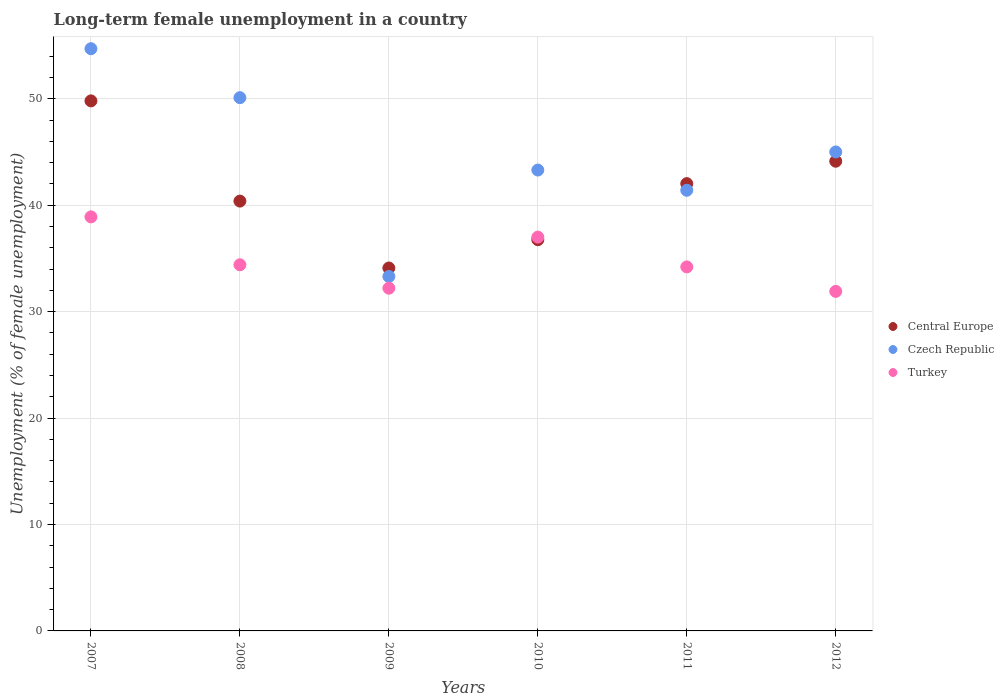How many different coloured dotlines are there?
Your answer should be very brief. 3. Is the number of dotlines equal to the number of legend labels?
Ensure brevity in your answer.  Yes. What is the percentage of long-term unemployed female population in Czech Republic in 2009?
Provide a succinct answer. 33.3. Across all years, what is the maximum percentage of long-term unemployed female population in Central Europe?
Your answer should be compact. 49.8. Across all years, what is the minimum percentage of long-term unemployed female population in Czech Republic?
Your answer should be compact. 33.3. In which year was the percentage of long-term unemployed female population in Central Europe minimum?
Offer a very short reply. 2009. What is the total percentage of long-term unemployed female population in Turkey in the graph?
Provide a short and direct response. 208.6. What is the difference between the percentage of long-term unemployed female population in Central Europe in 2008 and that in 2012?
Your response must be concise. -3.75. What is the difference between the percentage of long-term unemployed female population in Turkey in 2008 and the percentage of long-term unemployed female population in Central Europe in 2007?
Keep it short and to the point. -15.4. What is the average percentage of long-term unemployed female population in Czech Republic per year?
Provide a succinct answer. 44.63. In the year 2012, what is the difference between the percentage of long-term unemployed female population in Czech Republic and percentage of long-term unemployed female population in Turkey?
Give a very brief answer. 13.1. What is the ratio of the percentage of long-term unemployed female population in Central Europe in 2008 to that in 2009?
Offer a very short reply. 1.18. Is the difference between the percentage of long-term unemployed female population in Czech Republic in 2007 and 2008 greater than the difference between the percentage of long-term unemployed female population in Turkey in 2007 and 2008?
Your answer should be very brief. Yes. What is the difference between the highest and the second highest percentage of long-term unemployed female population in Turkey?
Offer a very short reply. 1.9. What is the difference between the highest and the lowest percentage of long-term unemployed female population in Turkey?
Provide a succinct answer. 7. Is the sum of the percentage of long-term unemployed female population in Czech Republic in 2009 and 2010 greater than the maximum percentage of long-term unemployed female population in Turkey across all years?
Offer a terse response. Yes. How many dotlines are there?
Your answer should be very brief. 3. How many years are there in the graph?
Give a very brief answer. 6. What is the difference between two consecutive major ticks on the Y-axis?
Keep it short and to the point. 10. Does the graph contain any zero values?
Keep it short and to the point. No. What is the title of the graph?
Your answer should be very brief. Long-term female unemployment in a country. What is the label or title of the X-axis?
Give a very brief answer. Years. What is the label or title of the Y-axis?
Keep it short and to the point. Unemployment (% of female unemployment). What is the Unemployment (% of female unemployment) of Central Europe in 2007?
Your answer should be very brief. 49.8. What is the Unemployment (% of female unemployment) of Czech Republic in 2007?
Ensure brevity in your answer.  54.7. What is the Unemployment (% of female unemployment) of Turkey in 2007?
Your answer should be very brief. 38.9. What is the Unemployment (% of female unemployment) of Central Europe in 2008?
Provide a short and direct response. 40.38. What is the Unemployment (% of female unemployment) in Czech Republic in 2008?
Offer a terse response. 50.1. What is the Unemployment (% of female unemployment) of Turkey in 2008?
Provide a short and direct response. 34.4. What is the Unemployment (% of female unemployment) of Central Europe in 2009?
Ensure brevity in your answer.  34.1. What is the Unemployment (% of female unemployment) of Czech Republic in 2009?
Provide a short and direct response. 33.3. What is the Unemployment (% of female unemployment) of Turkey in 2009?
Make the answer very short. 32.2. What is the Unemployment (% of female unemployment) in Central Europe in 2010?
Give a very brief answer. 36.75. What is the Unemployment (% of female unemployment) of Czech Republic in 2010?
Your answer should be compact. 43.3. What is the Unemployment (% of female unemployment) of Turkey in 2010?
Offer a very short reply. 37. What is the Unemployment (% of female unemployment) in Central Europe in 2011?
Offer a terse response. 42.02. What is the Unemployment (% of female unemployment) of Czech Republic in 2011?
Provide a short and direct response. 41.4. What is the Unemployment (% of female unemployment) of Turkey in 2011?
Your answer should be very brief. 34.2. What is the Unemployment (% of female unemployment) of Central Europe in 2012?
Give a very brief answer. 44.13. What is the Unemployment (% of female unemployment) of Turkey in 2012?
Offer a very short reply. 31.9. Across all years, what is the maximum Unemployment (% of female unemployment) of Central Europe?
Keep it short and to the point. 49.8. Across all years, what is the maximum Unemployment (% of female unemployment) of Czech Republic?
Your answer should be compact. 54.7. Across all years, what is the maximum Unemployment (% of female unemployment) in Turkey?
Make the answer very short. 38.9. Across all years, what is the minimum Unemployment (% of female unemployment) in Central Europe?
Ensure brevity in your answer.  34.1. Across all years, what is the minimum Unemployment (% of female unemployment) of Czech Republic?
Your answer should be very brief. 33.3. Across all years, what is the minimum Unemployment (% of female unemployment) of Turkey?
Your answer should be very brief. 31.9. What is the total Unemployment (% of female unemployment) in Central Europe in the graph?
Provide a short and direct response. 247.19. What is the total Unemployment (% of female unemployment) of Czech Republic in the graph?
Your response must be concise. 267.8. What is the total Unemployment (% of female unemployment) in Turkey in the graph?
Keep it short and to the point. 208.6. What is the difference between the Unemployment (% of female unemployment) in Central Europe in 2007 and that in 2008?
Your answer should be compact. 9.42. What is the difference between the Unemployment (% of female unemployment) of Turkey in 2007 and that in 2008?
Make the answer very short. 4.5. What is the difference between the Unemployment (% of female unemployment) in Central Europe in 2007 and that in 2009?
Make the answer very short. 15.7. What is the difference between the Unemployment (% of female unemployment) of Czech Republic in 2007 and that in 2009?
Your answer should be compact. 21.4. What is the difference between the Unemployment (% of female unemployment) of Turkey in 2007 and that in 2009?
Keep it short and to the point. 6.7. What is the difference between the Unemployment (% of female unemployment) in Central Europe in 2007 and that in 2010?
Keep it short and to the point. 13.04. What is the difference between the Unemployment (% of female unemployment) of Turkey in 2007 and that in 2010?
Provide a short and direct response. 1.9. What is the difference between the Unemployment (% of female unemployment) in Central Europe in 2007 and that in 2011?
Ensure brevity in your answer.  7.77. What is the difference between the Unemployment (% of female unemployment) of Central Europe in 2007 and that in 2012?
Provide a short and direct response. 5.67. What is the difference between the Unemployment (% of female unemployment) in Czech Republic in 2007 and that in 2012?
Offer a terse response. 9.7. What is the difference between the Unemployment (% of female unemployment) in Central Europe in 2008 and that in 2009?
Give a very brief answer. 6.29. What is the difference between the Unemployment (% of female unemployment) of Czech Republic in 2008 and that in 2009?
Offer a terse response. 16.8. What is the difference between the Unemployment (% of female unemployment) in Turkey in 2008 and that in 2009?
Offer a terse response. 2.2. What is the difference between the Unemployment (% of female unemployment) of Central Europe in 2008 and that in 2010?
Ensure brevity in your answer.  3.63. What is the difference between the Unemployment (% of female unemployment) in Turkey in 2008 and that in 2010?
Ensure brevity in your answer.  -2.6. What is the difference between the Unemployment (% of female unemployment) in Central Europe in 2008 and that in 2011?
Your answer should be compact. -1.64. What is the difference between the Unemployment (% of female unemployment) in Czech Republic in 2008 and that in 2011?
Offer a terse response. 8.7. What is the difference between the Unemployment (% of female unemployment) of Central Europe in 2008 and that in 2012?
Offer a very short reply. -3.75. What is the difference between the Unemployment (% of female unemployment) of Central Europe in 2009 and that in 2010?
Your answer should be compact. -2.66. What is the difference between the Unemployment (% of female unemployment) in Central Europe in 2009 and that in 2011?
Your answer should be compact. -7.93. What is the difference between the Unemployment (% of female unemployment) of Turkey in 2009 and that in 2011?
Keep it short and to the point. -2. What is the difference between the Unemployment (% of female unemployment) in Central Europe in 2009 and that in 2012?
Keep it short and to the point. -10.03. What is the difference between the Unemployment (% of female unemployment) in Czech Republic in 2009 and that in 2012?
Your answer should be compact. -11.7. What is the difference between the Unemployment (% of female unemployment) in Turkey in 2009 and that in 2012?
Provide a succinct answer. 0.3. What is the difference between the Unemployment (% of female unemployment) in Central Europe in 2010 and that in 2011?
Offer a very short reply. -5.27. What is the difference between the Unemployment (% of female unemployment) of Czech Republic in 2010 and that in 2011?
Your answer should be compact. 1.9. What is the difference between the Unemployment (% of female unemployment) in Central Europe in 2010 and that in 2012?
Your answer should be compact. -7.37. What is the difference between the Unemployment (% of female unemployment) of Turkey in 2010 and that in 2012?
Ensure brevity in your answer.  5.1. What is the difference between the Unemployment (% of female unemployment) in Central Europe in 2011 and that in 2012?
Provide a succinct answer. -2.1. What is the difference between the Unemployment (% of female unemployment) of Central Europe in 2007 and the Unemployment (% of female unemployment) of Czech Republic in 2008?
Give a very brief answer. -0.3. What is the difference between the Unemployment (% of female unemployment) in Central Europe in 2007 and the Unemployment (% of female unemployment) in Turkey in 2008?
Make the answer very short. 15.4. What is the difference between the Unemployment (% of female unemployment) of Czech Republic in 2007 and the Unemployment (% of female unemployment) of Turkey in 2008?
Provide a short and direct response. 20.3. What is the difference between the Unemployment (% of female unemployment) of Central Europe in 2007 and the Unemployment (% of female unemployment) of Czech Republic in 2009?
Offer a very short reply. 16.5. What is the difference between the Unemployment (% of female unemployment) in Central Europe in 2007 and the Unemployment (% of female unemployment) in Turkey in 2009?
Your answer should be very brief. 17.6. What is the difference between the Unemployment (% of female unemployment) in Central Europe in 2007 and the Unemployment (% of female unemployment) in Czech Republic in 2010?
Your response must be concise. 6.5. What is the difference between the Unemployment (% of female unemployment) in Central Europe in 2007 and the Unemployment (% of female unemployment) in Turkey in 2010?
Your answer should be compact. 12.8. What is the difference between the Unemployment (% of female unemployment) of Czech Republic in 2007 and the Unemployment (% of female unemployment) of Turkey in 2010?
Keep it short and to the point. 17.7. What is the difference between the Unemployment (% of female unemployment) of Central Europe in 2007 and the Unemployment (% of female unemployment) of Czech Republic in 2011?
Make the answer very short. 8.4. What is the difference between the Unemployment (% of female unemployment) of Central Europe in 2007 and the Unemployment (% of female unemployment) of Turkey in 2011?
Your answer should be very brief. 15.6. What is the difference between the Unemployment (% of female unemployment) of Czech Republic in 2007 and the Unemployment (% of female unemployment) of Turkey in 2011?
Give a very brief answer. 20.5. What is the difference between the Unemployment (% of female unemployment) of Central Europe in 2007 and the Unemployment (% of female unemployment) of Czech Republic in 2012?
Your answer should be compact. 4.8. What is the difference between the Unemployment (% of female unemployment) in Central Europe in 2007 and the Unemployment (% of female unemployment) in Turkey in 2012?
Give a very brief answer. 17.9. What is the difference between the Unemployment (% of female unemployment) in Czech Republic in 2007 and the Unemployment (% of female unemployment) in Turkey in 2012?
Make the answer very short. 22.8. What is the difference between the Unemployment (% of female unemployment) in Central Europe in 2008 and the Unemployment (% of female unemployment) in Czech Republic in 2009?
Provide a short and direct response. 7.08. What is the difference between the Unemployment (% of female unemployment) of Central Europe in 2008 and the Unemployment (% of female unemployment) of Turkey in 2009?
Give a very brief answer. 8.18. What is the difference between the Unemployment (% of female unemployment) in Central Europe in 2008 and the Unemployment (% of female unemployment) in Czech Republic in 2010?
Give a very brief answer. -2.92. What is the difference between the Unemployment (% of female unemployment) of Central Europe in 2008 and the Unemployment (% of female unemployment) of Turkey in 2010?
Offer a terse response. 3.38. What is the difference between the Unemployment (% of female unemployment) of Czech Republic in 2008 and the Unemployment (% of female unemployment) of Turkey in 2010?
Ensure brevity in your answer.  13.1. What is the difference between the Unemployment (% of female unemployment) of Central Europe in 2008 and the Unemployment (% of female unemployment) of Czech Republic in 2011?
Your response must be concise. -1.02. What is the difference between the Unemployment (% of female unemployment) in Central Europe in 2008 and the Unemployment (% of female unemployment) in Turkey in 2011?
Make the answer very short. 6.18. What is the difference between the Unemployment (% of female unemployment) of Czech Republic in 2008 and the Unemployment (% of female unemployment) of Turkey in 2011?
Offer a terse response. 15.9. What is the difference between the Unemployment (% of female unemployment) in Central Europe in 2008 and the Unemployment (% of female unemployment) in Czech Republic in 2012?
Make the answer very short. -4.62. What is the difference between the Unemployment (% of female unemployment) of Central Europe in 2008 and the Unemployment (% of female unemployment) of Turkey in 2012?
Make the answer very short. 8.48. What is the difference between the Unemployment (% of female unemployment) in Central Europe in 2009 and the Unemployment (% of female unemployment) in Czech Republic in 2010?
Make the answer very short. -9.2. What is the difference between the Unemployment (% of female unemployment) of Central Europe in 2009 and the Unemployment (% of female unemployment) of Turkey in 2010?
Your response must be concise. -2.9. What is the difference between the Unemployment (% of female unemployment) in Central Europe in 2009 and the Unemployment (% of female unemployment) in Czech Republic in 2011?
Offer a terse response. -7.3. What is the difference between the Unemployment (% of female unemployment) in Central Europe in 2009 and the Unemployment (% of female unemployment) in Turkey in 2011?
Provide a succinct answer. -0.1. What is the difference between the Unemployment (% of female unemployment) of Czech Republic in 2009 and the Unemployment (% of female unemployment) of Turkey in 2011?
Make the answer very short. -0.9. What is the difference between the Unemployment (% of female unemployment) in Central Europe in 2009 and the Unemployment (% of female unemployment) in Czech Republic in 2012?
Your response must be concise. -10.9. What is the difference between the Unemployment (% of female unemployment) of Central Europe in 2009 and the Unemployment (% of female unemployment) of Turkey in 2012?
Make the answer very short. 2.2. What is the difference between the Unemployment (% of female unemployment) of Central Europe in 2010 and the Unemployment (% of female unemployment) of Czech Republic in 2011?
Give a very brief answer. -4.65. What is the difference between the Unemployment (% of female unemployment) of Central Europe in 2010 and the Unemployment (% of female unemployment) of Turkey in 2011?
Your response must be concise. 2.55. What is the difference between the Unemployment (% of female unemployment) of Czech Republic in 2010 and the Unemployment (% of female unemployment) of Turkey in 2011?
Ensure brevity in your answer.  9.1. What is the difference between the Unemployment (% of female unemployment) in Central Europe in 2010 and the Unemployment (% of female unemployment) in Czech Republic in 2012?
Offer a terse response. -8.25. What is the difference between the Unemployment (% of female unemployment) of Central Europe in 2010 and the Unemployment (% of female unemployment) of Turkey in 2012?
Keep it short and to the point. 4.85. What is the difference between the Unemployment (% of female unemployment) in Czech Republic in 2010 and the Unemployment (% of female unemployment) in Turkey in 2012?
Your answer should be very brief. 11.4. What is the difference between the Unemployment (% of female unemployment) in Central Europe in 2011 and the Unemployment (% of female unemployment) in Czech Republic in 2012?
Your answer should be very brief. -2.98. What is the difference between the Unemployment (% of female unemployment) in Central Europe in 2011 and the Unemployment (% of female unemployment) in Turkey in 2012?
Ensure brevity in your answer.  10.12. What is the average Unemployment (% of female unemployment) in Central Europe per year?
Your answer should be very brief. 41.2. What is the average Unemployment (% of female unemployment) in Czech Republic per year?
Make the answer very short. 44.63. What is the average Unemployment (% of female unemployment) of Turkey per year?
Make the answer very short. 34.77. In the year 2007, what is the difference between the Unemployment (% of female unemployment) in Central Europe and Unemployment (% of female unemployment) in Czech Republic?
Your answer should be very brief. -4.9. In the year 2007, what is the difference between the Unemployment (% of female unemployment) of Central Europe and Unemployment (% of female unemployment) of Turkey?
Your answer should be very brief. 10.9. In the year 2008, what is the difference between the Unemployment (% of female unemployment) of Central Europe and Unemployment (% of female unemployment) of Czech Republic?
Offer a terse response. -9.72. In the year 2008, what is the difference between the Unemployment (% of female unemployment) of Central Europe and Unemployment (% of female unemployment) of Turkey?
Your answer should be very brief. 5.98. In the year 2009, what is the difference between the Unemployment (% of female unemployment) in Central Europe and Unemployment (% of female unemployment) in Czech Republic?
Keep it short and to the point. 0.8. In the year 2009, what is the difference between the Unemployment (% of female unemployment) in Central Europe and Unemployment (% of female unemployment) in Turkey?
Give a very brief answer. 1.9. In the year 2009, what is the difference between the Unemployment (% of female unemployment) of Czech Republic and Unemployment (% of female unemployment) of Turkey?
Your answer should be compact. 1.1. In the year 2010, what is the difference between the Unemployment (% of female unemployment) of Central Europe and Unemployment (% of female unemployment) of Czech Republic?
Your answer should be compact. -6.55. In the year 2010, what is the difference between the Unemployment (% of female unemployment) in Central Europe and Unemployment (% of female unemployment) in Turkey?
Give a very brief answer. -0.25. In the year 2010, what is the difference between the Unemployment (% of female unemployment) in Czech Republic and Unemployment (% of female unemployment) in Turkey?
Keep it short and to the point. 6.3. In the year 2011, what is the difference between the Unemployment (% of female unemployment) of Central Europe and Unemployment (% of female unemployment) of Czech Republic?
Make the answer very short. 0.62. In the year 2011, what is the difference between the Unemployment (% of female unemployment) in Central Europe and Unemployment (% of female unemployment) in Turkey?
Give a very brief answer. 7.82. In the year 2011, what is the difference between the Unemployment (% of female unemployment) of Czech Republic and Unemployment (% of female unemployment) of Turkey?
Your response must be concise. 7.2. In the year 2012, what is the difference between the Unemployment (% of female unemployment) of Central Europe and Unemployment (% of female unemployment) of Czech Republic?
Your answer should be very brief. -0.87. In the year 2012, what is the difference between the Unemployment (% of female unemployment) of Central Europe and Unemployment (% of female unemployment) of Turkey?
Your answer should be compact. 12.23. In the year 2012, what is the difference between the Unemployment (% of female unemployment) in Czech Republic and Unemployment (% of female unemployment) in Turkey?
Your response must be concise. 13.1. What is the ratio of the Unemployment (% of female unemployment) of Central Europe in 2007 to that in 2008?
Offer a very short reply. 1.23. What is the ratio of the Unemployment (% of female unemployment) of Czech Republic in 2007 to that in 2008?
Provide a succinct answer. 1.09. What is the ratio of the Unemployment (% of female unemployment) of Turkey in 2007 to that in 2008?
Your answer should be compact. 1.13. What is the ratio of the Unemployment (% of female unemployment) of Central Europe in 2007 to that in 2009?
Offer a very short reply. 1.46. What is the ratio of the Unemployment (% of female unemployment) in Czech Republic in 2007 to that in 2009?
Your answer should be compact. 1.64. What is the ratio of the Unemployment (% of female unemployment) in Turkey in 2007 to that in 2009?
Your response must be concise. 1.21. What is the ratio of the Unemployment (% of female unemployment) in Central Europe in 2007 to that in 2010?
Provide a short and direct response. 1.35. What is the ratio of the Unemployment (% of female unemployment) of Czech Republic in 2007 to that in 2010?
Provide a short and direct response. 1.26. What is the ratio of the Unemployment (% of female unemployment) in Turkey in 2007 to that in 2010?
Your response must be concise. 1.05. What is the ratio of the Unemployment (% of female unemployment) in Central Europe in 2007 to that in 2011?
Your answer should be very brief. 1.19. What is the ratio of the Unemployment (% of female unemployment) in Czech Republic in 2007 to that in 2011?
Offer a very short reply. 1.32. What is the ratio of the Unemployment (% of female unemployment) of Turkey in 2007 to that in 2011?
Your answer should be very brief. 1.14. What is the ratio of the Unemployment (% of female unemployment) in Central Europe in 2007 to that in 2012?
Ensure brevity in your answer.  1.13. What is the ratio of the Unemployment (% of female unemployment) of Czech Republic in 2007 to that in 2012?
Your answer should be compact. 1.22. What is the ratio of the Unemployment (% of female unemployment) of Turkey in 2007 to that in 2012?
Provide a short and direct response. 1.22. What is the ratio of the Unemployment (% of female unemployment) in Central Europe in 2008 to that in 2009?
Give a very brief answer. 1.18. What is the ratio of the Unemployment (% of female unemployment) of Czech Republic in 2008 to that in 2009?
Offer a very short reply. 1.5. What is the ratio of the Unemployment (% of female unemployment) in Turkey in 2008 to that in 2009?
Provide a succinct answer. 1.07. What is the ratio of the Unemployment (% of female unemployment) of Central Europe in 2008 to that in 2010?
Ensure brevity in your answer.  1.1. What is the ratio of the Unemployment (% of female unemployment) in Czech Republic in 2008 to that in 2010?
Offer a terse response. 1.16. What is the ratio of the Unemployment (% of female unemployment) in Turkey in 2008 to that in 2010?
Offer a terse response. 0.93. What is the ratio of the Unemployment (% of female unemployment) of Czech Republic in 2008 to that in 2011?
Your answer should be very brief. 1.21. What is the ratio of the Unemployment (% of female unemployment) of Turkey in 2008 to that in 2011?
Offer a terse response. 1.01. What is the ratio of the Unemployment (% of female unemployment) of Central Europe in 2008 to that in 2012?
Make the answer very short. 0.92. What is the ratio of the Unemployment (% of female unemployment) of Czech Republic in 2008 to that in 2012?
Offer a terse response. 1.11. What is the ratio of the Unemployment (% of female unemployment) of Turkey in 2008 to that in 2012?
Offer a very short reply. 1.08. What is the ratio of the Unemployment (% of female unemployment) of Central Europe in 2009 to that in 2010?
Provide a succinct answer. 0.93. What is the ratio of the Unemployment (% of female unemployment) in Czech Republic in 2009 to that in 2010?
Give a very brief answer. 0.77. What is the ratio of the Unemployment (% of female unemployment) in Turkey in 2009 to that in 2010?
Provide a succinct answer. 0.87. What is the ratio of the Unemployment (% of female unemployment) of Central Europe in 2009 to that in 2011?
Your response must be concise. 0.81. What is the ratio of the Unemployment (% of female unemployment) in Czech Republic in 2009 to that in 2011?
Your answer should be very brief. 0.8. What is the ratio of the Unemployment (% of female unemployment) in Turkey in 2009 to that in 2011?
Give a very brief answer. 0.94. What is the ratio of the Unemployment (% of female unemployment) of Central Europe in 2009 to that in 2012?
Keep it short and to the point. 0.77. What is the ratio of the Unemployment (% of female unemployment) in Czech Republic in 2009 to that in 2012?
Keep it short and to the point. 0.74. What is the ratio of the Unemployment (% of female unemployment) in Turkey in 2009 to that in 2012?
Give a very brief answer. 1.01. What is the ratio of the Unemployment (% of female unemployment) in Central Europe in 2010 to that in 2011?
Ensure brevity in your answer.  0.87. What is the ratio of the Unemployment (% of female unemployment) of Czech Republic in 2010 to that in 2011?
Offer a very short reply. 1.05. What is the ratio of the Unemployment (% of female unemployment) in Turkey in 2010 to that in 2011?
Your answer should be compact. 1.08. What is the ratio of the Unemployment (% of female unemployment) in Central Europe in 2010 to that in 2012?
Provide a short and direct response. 0.83. What is the ratio of the Unemployment (% of female unemployment) in Czech Republic in 2010 to that in 2012?
Ensure brevity in your answer.  0.96. What is the ratio of the Unemployment (% of female unemployment) of Turkey in 2010 to that in 2012?
Ensure brevity in your answer.  1.16. What is the ratio of the Unemployment (% of female unemployment) of Central Europe in 2011 to that in 2012?
Give a very brief answer. 0.95. What is the ratio of the Unemployment (% of female unemployment) in Czech Republic in 2011 to that in 2012?
Offer a terse response. 0.92. What is the ratio of the Unemployment (% of female unemployment) in Turkey in 2011 to that in 2012?
Offer a very short reply. 1.07. What is the difference between the highest and the second highest Unemployment (% of female unemployment) of Central Europe?
Your answer should be compact. 5.67. What is the difference between the highest and the second highest Unemployment (% of female unemployment) in Czech Republic?
Make the answer very short. 4.6. What is the difference between the highest and the lowest Unemployment (% of female unemployment) of Central Europe?
Provide a short and direct response. 15.7. What is the difference between the highest and the lowest Unemployment (% of female unemployment) of Czech Republic?
Your response must be concise. 21.4. What is the difference between the highest and the lowest Unemployment (% of female unemployment) of Turkey?
Your answer should be compact. 7. 